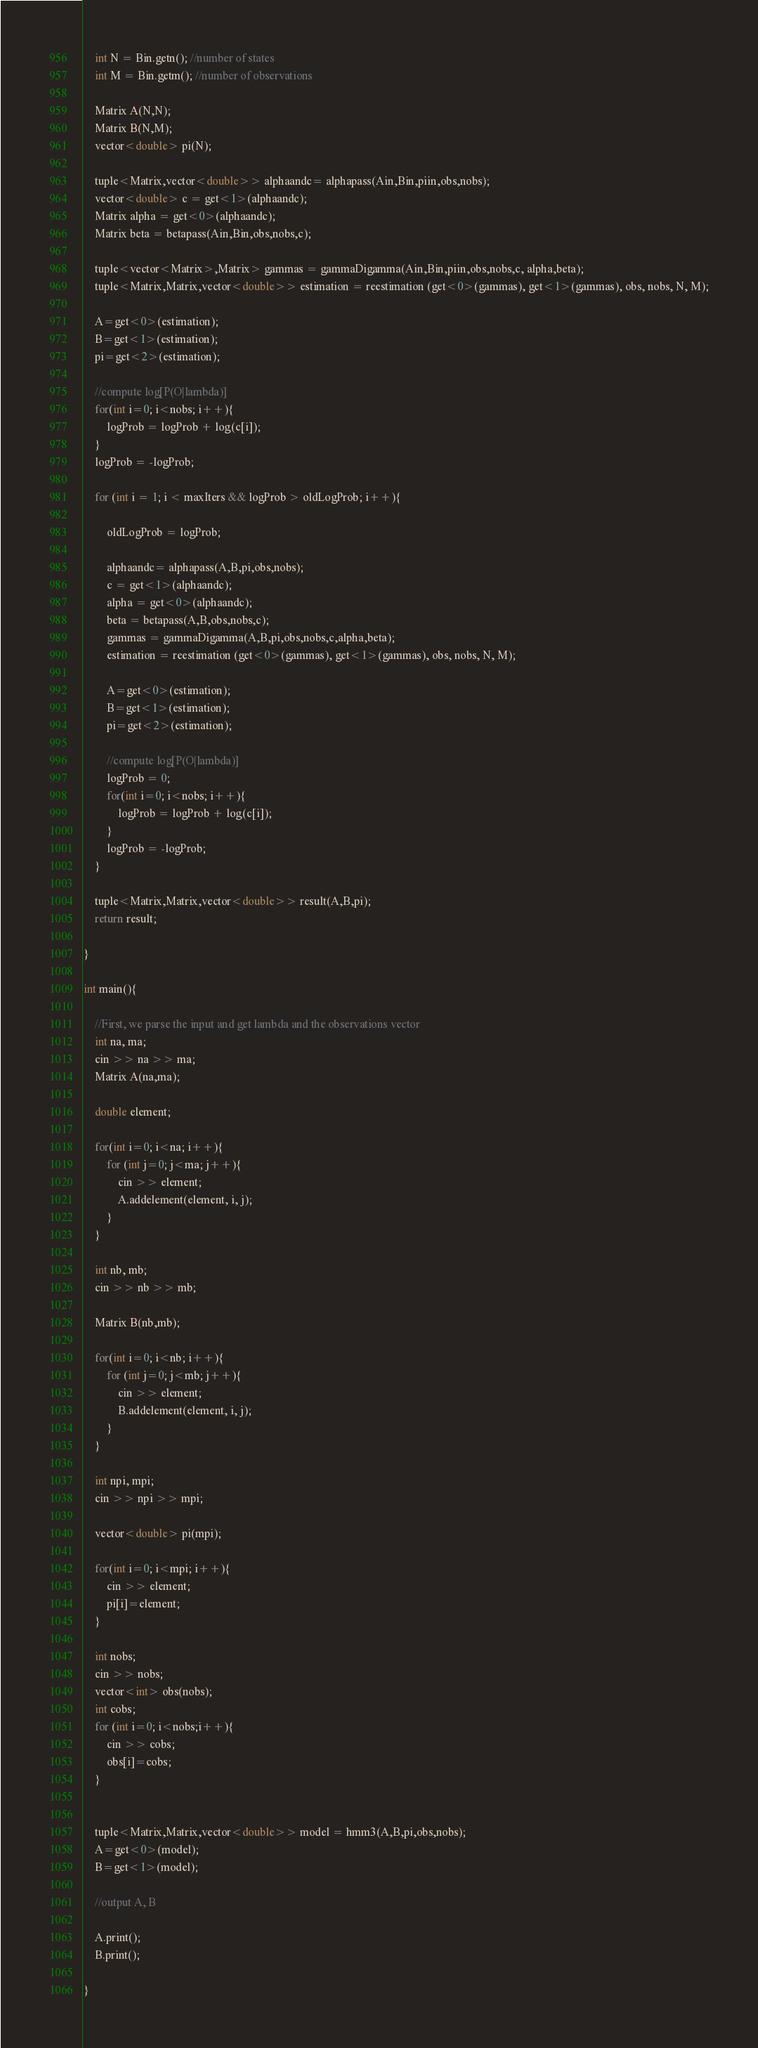Convert code to text. <code><loc_0><loc_0><loc_500><loc_500><_C++_>    int N = Bin.getn(); //number of states
    int M = Bin.getm(); //number of observations

    Matrix A(N,N);
    Matrix B(N,M);
    vector<double> pi(N);

    tuple<Matrix,vector<double>> alphaandc= alphapass(Ain,Bin,piin,obs,nobs);
    vector<double> c = get<1>(alphaandc);
    Matrix alpha = get<0>(alphaandc);
    Matrix beta = betapass(Ain,Bin,obs,nobs,c);

    tuple<vector<Matrix>,Matrix> gammas = gammaDigamma(Ain,Bin,piin,obs,nobs,c, alpha,beta);
    tuple<Matrix,Matrix,vector<double>> estimation = reestimation (get<0>(gammas), get<1>(gammas), obs, nobs, N, M);

    A=get<0>(estimation);
    B=get<1>(estimation);
    pi=get<2>(estimation);

    //compute log[P(O|lambda)]
    for(int i=0; i<nobs; i++){
        logProb = logProb + log(c[i]);
    }
    logProb = -logProb;

    for (int i = 1; i < maxIters && logProb > oldLogProb; i++){

        oldLogProb = logProb;

        alphaandc= alphapass(A,B,pi,obs,nobs);
        c = get<1>(alphaandc);
        alpha = get<0>(alphaandc);
        beta = betapass(A,B,obs,nobs,c);
        gammas = gammaDigamma(A,B,pi,obs,nobs,c,alpha,beta);
        estimation = reestimation (get<0>(gammas), get<1>(gammas), obs, nobs, N, M);

        A=get<0>(estimation);
        B=get<1>(estimation);
        pi=get<2>(estimation);
    
        //compute log[P(O|lambda)]
        logProb = 0;
        for(int i=0; i<nobs; i++){
            logProb = logProb + log(c[i]);
        }
        logProb = -logProb;
    }
    
    tuple<Matrix,Matrix,vector<double>> result(A,B,pi);
    return result;   

}

int main(){

    //First, we parse the input and get lambda and the observations vector
    int na, ma;
    cin >> na >> ma;
    Matrix A(na,ma);

    double element;

    for(int i=0; i<na; i++){
        for (int j=0; j<ma; j++){
            cin >> element;
            A.addelement(element, i, j);
        }
    }

    int nb, mb;
    cin >> nb >> mb;

    Matrix B(nb,mb);

    for(int i=0; i<nb; i++){
        for (int j=0; j<mb; j++){
            cin >> element;
            B.addelement(element, i, j);
        }
    }

    int npi, mpi;
    cin >> npi >> mpi;

    vector<double> pi(mpi);

    for(int i=0; i<mpi; i++){
        cin >> element;
        pi[i]=element;   
    }

    int nobs;
    cin >> nobs;
    vector<int> obs(nobs);
    int cobs;
    for (int i=0; i<nobs;i++){
        cin >> cobs;
        obs[i]=cobs;
    }


    tuple<Matrix,Matrix,vector<double>> model = hmm3(A,B,pi,obs,nobs);
    A=get<0>(model);
    B=get<1>(model);

    //output A, B

    A.print();
    B.print();
    
}
</code> 